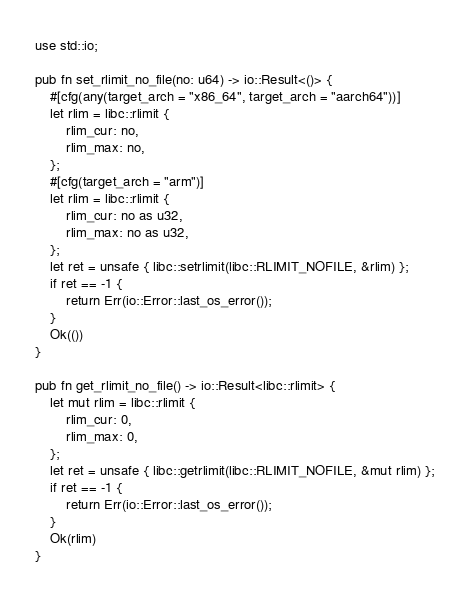Convert code to text. <code><loc_0><loc_0><loc_500><loc_500><_Rust_>use std::io;

pub fn set_rlimit_no_file(no: u64) -> io::Result<()> {
    #[cfg(any(target_arch = "x86_64", target_arch = "aarch64"))]
    let rlim = libc::rlimit {
        rlim_cur: no,
        rlim_max: no,
    };
    #[cfg(target_arch = "arm")]
    let rlim = libc::rlimit {
        rlim_cur: no as u32,
        rlim_max: no as u32,
    };
    let ret = unsafe { libc::setrlimit(libc::RLIMIT_NOFILE, &rlim) };
    if ret == -1 {
        return Err(io::Error::last_os_error());
    }
    Ok(())
}

pub fn get_rlimit_no_file() -> io::Result<libc::rlimit> {
    let mut rlim = libc::rlimit {
        rlim_cur: 0,
        rlim_max: 0,
    };
    let ret = unsafe { libc::getrlimit(libc::RLIMIT_NOFILE, &mut rlim) };
    if ret == -1 {
        return Err(io::Error::last_os_error());
    }
    Ok(rlim)
}
</code> 